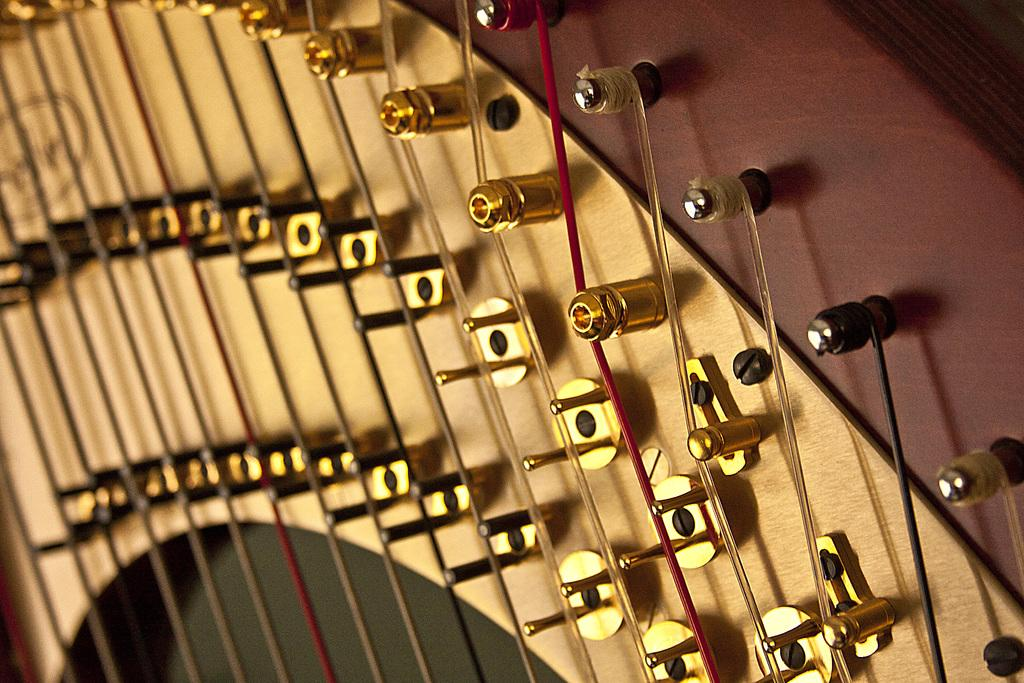What type of musical instrument is in the image? There is a harp musical instrument in the image. What feature of the harp is mentioned in the facts? The harp has strings. What type of ground can be seen beneath the harp in the image? There is no ground visible in the image; only the harp is present. 